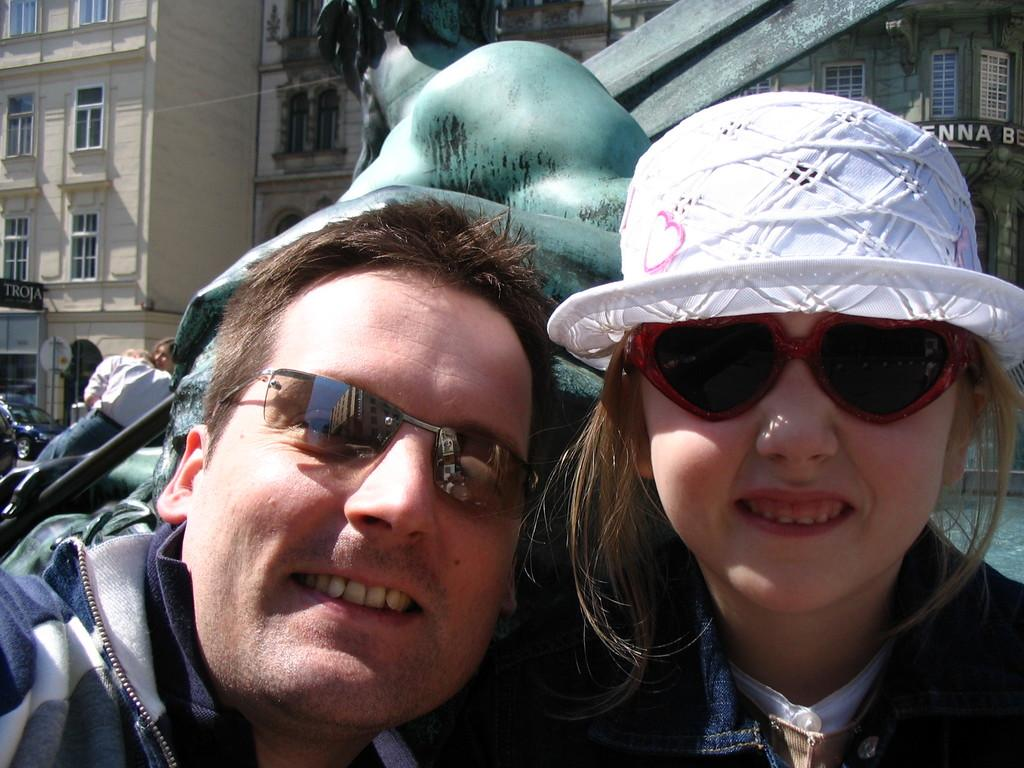Who is present in the image? There is a couple in the image. What is the couple doing in the image? The couple is smiling. What can be seen in the background of the image? There are buildings in the background of the image. Are there any other people visible in the image besides the couple? Yes, there is at least one person in the background of the image. What type of button is the manager wearing on their shirt in the image? There is no manager or shirt present in the image; it features a couple smiling with buildings in the background. 